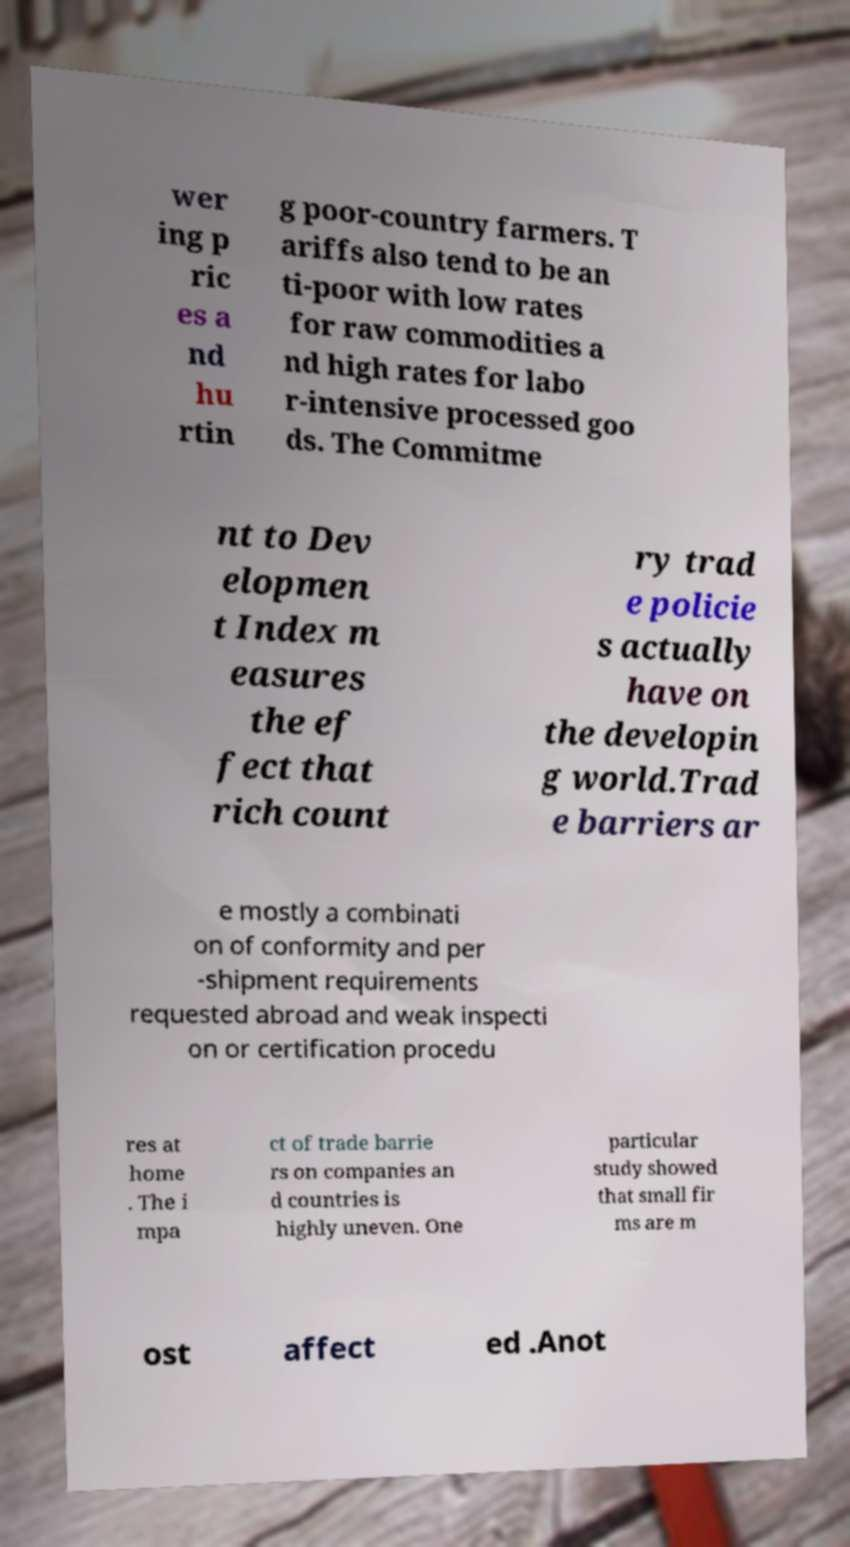There's text embedded in this image that I need extracted. Can you transcribe it verbatim? wer ing p ric es a nd hu rtin g poor-country farmers. T ariffs also tend to be an ti-poor with low rates for raw commodities a nd high rates for labo r-intensive processed goo ds. The Commitme nt to Dev elopmen t Index m easures the ef fect that rich count ry trad e policie s actually have on the developin g world.Trad e barriers ar e mostly a combinati on of conformity and per -shipment requirements requested abroad and weak inspecti on or certification procedu res at home . The i mpa ct of trade barrie rs on companies an d countries is highly uneven. One particular study showed that small fir ms are m ost affect ed .Anot 